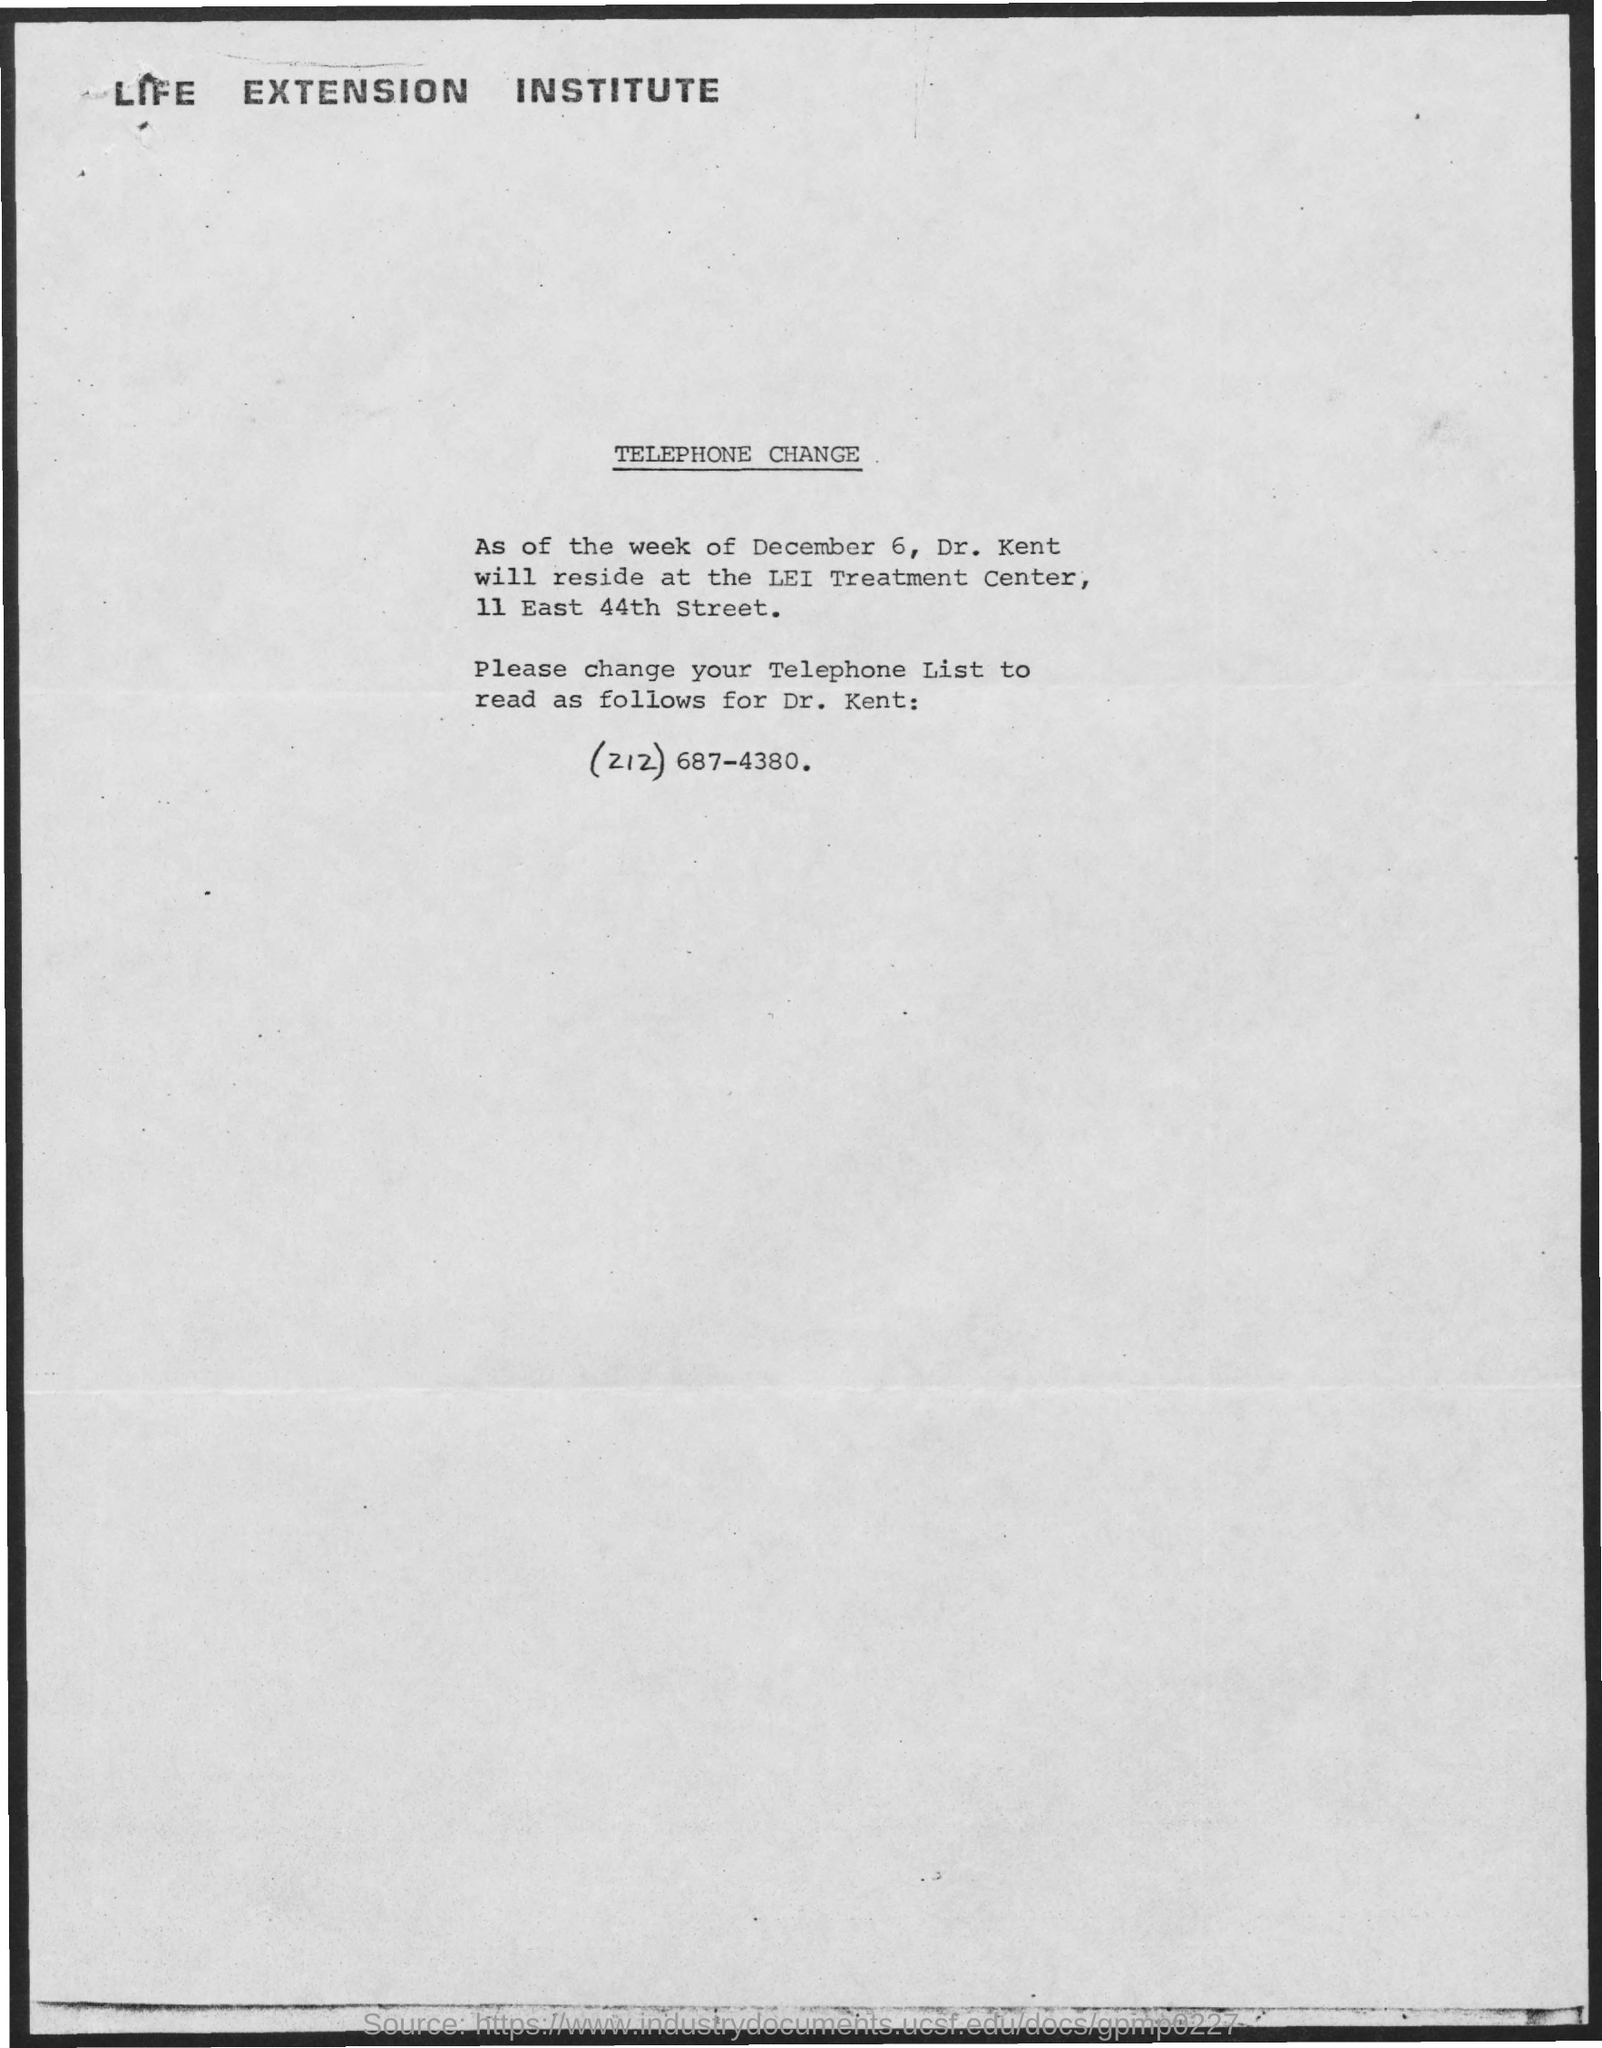Identify some key points in this picture. The telephone number is (212) 687-4380. The first title in the document is 'LIFE EXTENSION INSTITUTE.' The second title in the document is "Telephone Change... 